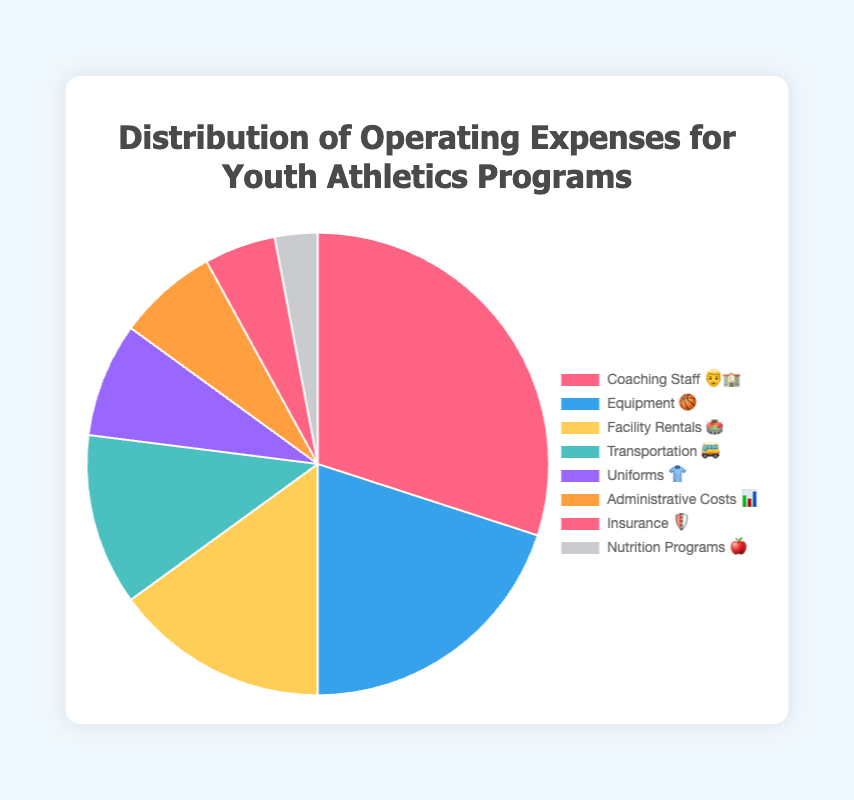What's the largest expense category? According to the chart, the largest section of the pie is labeled "Coaching Staff 👨‍🏫", representing 30% of the total operating expenses.
Answer: Coaching Staff 👨‍🏫 What percentage of the expenses is for equipment? The chart shows that the section for "Equipment 🏀" is labeled with 20%.
Answer: 20% How much more is spent on Coaching Staff compared to Transportation? Coaching Staff is 30% and Transportation is 12%. The difference is 30% - 12% = 18%.
Answer: 18% What is the sum of the percentages for Facility Rentals and Administrative Costs? Facility Rentals are 15% and Administrative Costs are 7%. Summing them up gives 15% + 7% = 22%.
Answer: 22% Which expense category is the least, and what is its percentage? The smallest section of the pie chart is "Nutrition Programs 🍎", which represents 3% of the expenses.
Answer: Nutrition Programs 🍎, 3% Compare the percentages of Uniforms and Insurance. Which one is greater? Uniforms have an 8% share while Insurance has a 5% share. 8% is greater than 5%.
Answer: Uniforms 👕, 8% What is the combined percentage of coaching staff, equipment, and facility rentals? The percentages for Coaching Staff, Equipment, and Facility Rentals are 30%, 20%, and 15% respectively. Summing them gives 30% + 20% + 15% = 65%.
Answer: 65% By how much does the percentage of Equipment expenses differ from that of Administrative Costs? Equipment expenses are 20% while Administrative Costs are 7%. The difference is 20% - 7% = 13%.
Answer: 13% How many expense categories are depicted in the chart? Counting the individual sections, there are 8 different expense categories shown in the chart.
Answer: 8 